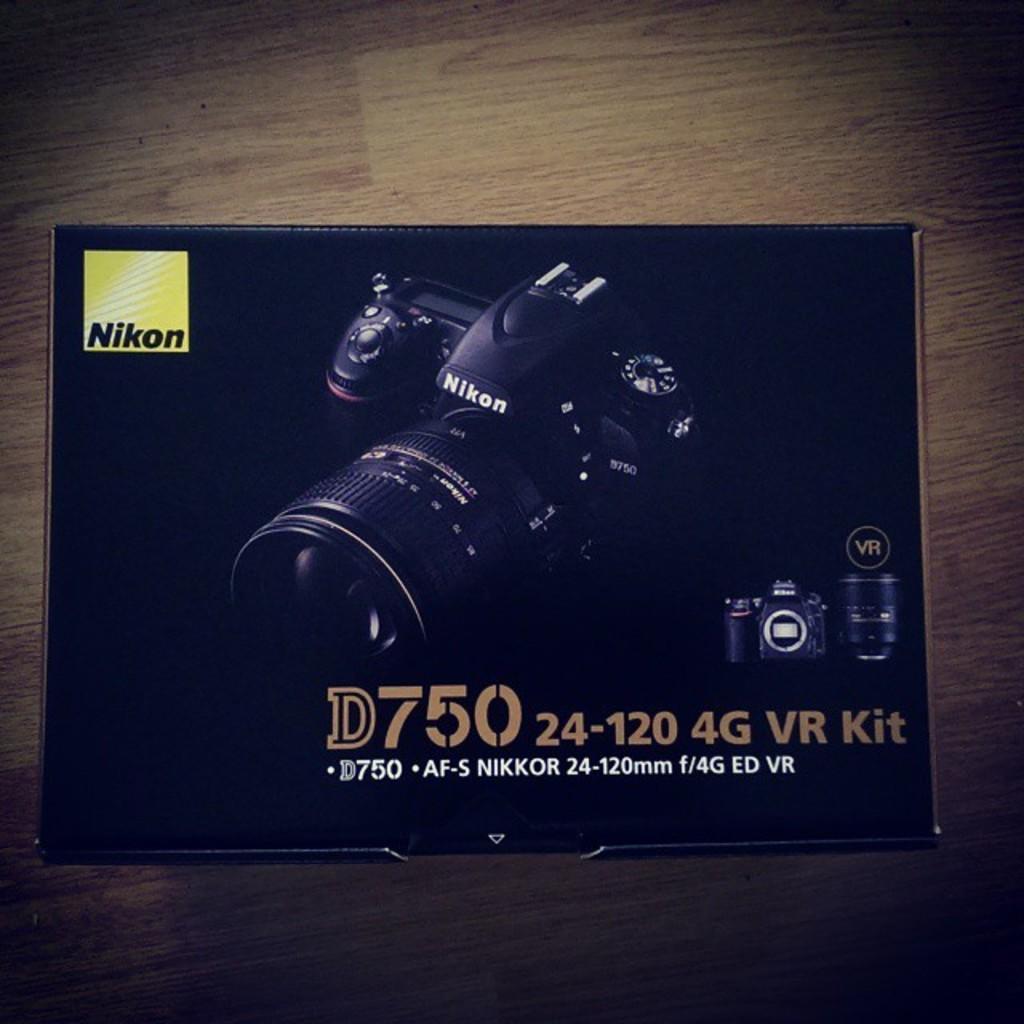Can you describe this image briefly? In the center of this picture we can see a paper on which we can see the text, numbers and the pictures of camera. In the background we can see a wooden object. 